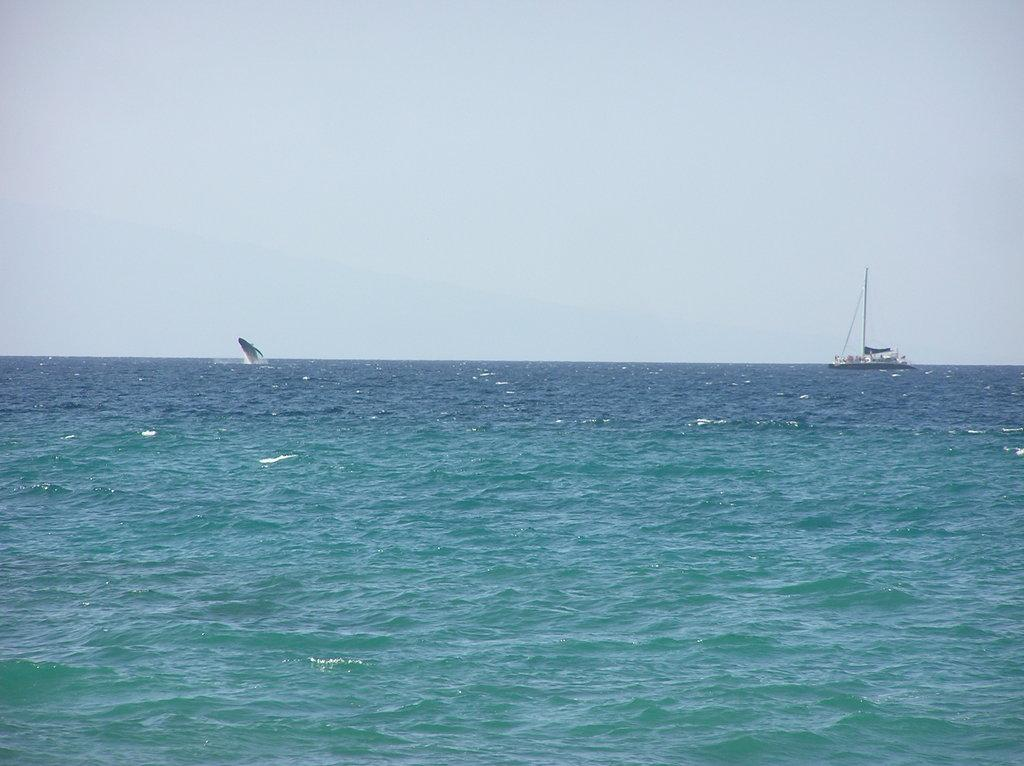What is located above the water in the image? There is a boat above the water in the image. What object can be seen in the image that is not related to the boat or water? There is a pole in the image. What type of sea creature is present in the image? There is a sea animal in the image. What can be seen in the background of the image? The sky is visible in the background of the image. What type of calculator can be seen floating in the water in the image? There is no calculator present in the image; it features a boat above the water, a pole, a sea animal, and a visible sky in the background. 